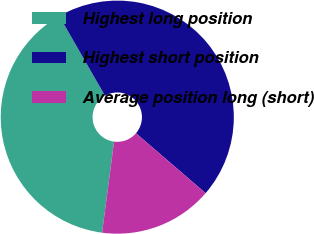Convert chart. <chart><loc_0><loc_0><loc_500><loc_500><pie_chart><fcel>Highest long position<fcel>Highest short position<fcel>Average position long (short)<nl><fcel>39.63%<fcel>44.6%<fcel>15.77%<nl></chart> 